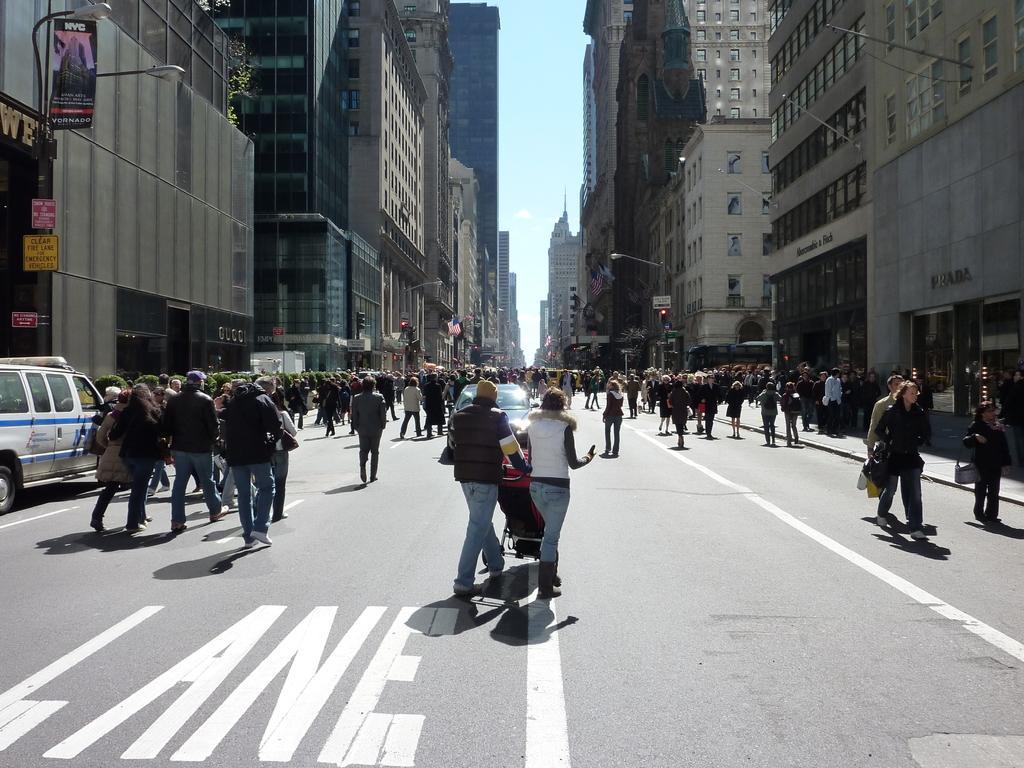How would you summarize this image in a sentence or two? As we can see in the image there are buildings, street lamps, banner, windows, traffic signals, car and group of people. In the front there is a wheelchair. At the top there is sky. 